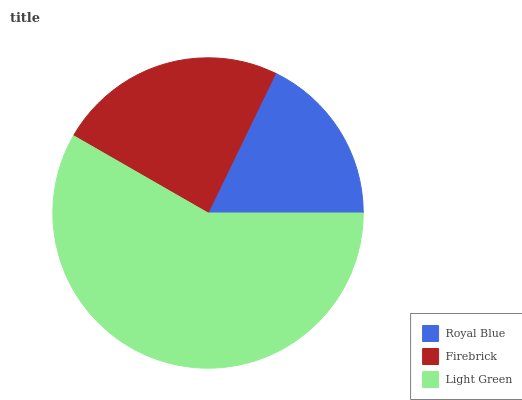Is Royal Blue the minimum?
Answer yes or no. Yes. Is Light Green the maximum?
Answer yes or no. Yes. Is Firebrick the minimum?
Answer yes or no. No. Is Firebrick the maximum?
Answer yes or no. No. Is Firebrick greater than Royal Blue?
Answer yes or no. Yes. Is Royal Blue less than Firebrick?
Answer yes or no. Yes. Is Royal Blue greater than Firebrick?
Answer yes or no. No. Is Firebrick less than Royal Blue?
Answer yes or no. No. Is Firebrick the high median?
Answer yes or no. Yes. Is Firebrick the low median?
Answer yes or no. Yes. Is Royal Blue the high median?
Answer yes or no. No. Is Royal Blue the low median?
Answer yes or no. No. 